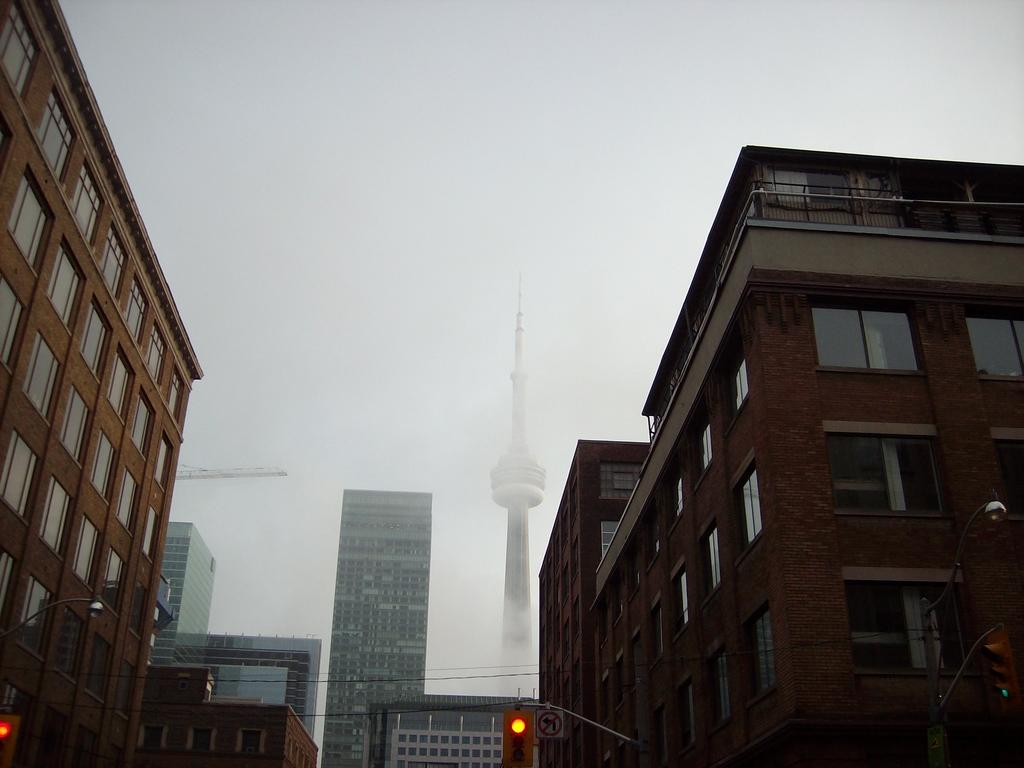What can be seen in the image that helps regulate traffic? There are traffic signals in the image. What else can be seen in the image that provides information? There is a signboard in the image. What type of structures can be seen in the background of the image? There are buildings in the background of the image. How many chickens are standing on the traffic signals in the image? There are no chickens present in the image, and they are not standing on the traffic signals. 